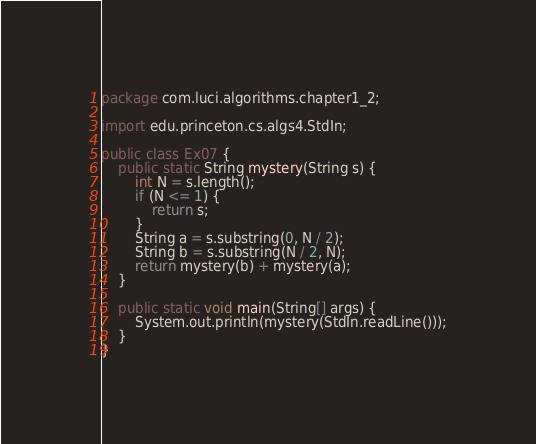Convert code to text. <code><loc_0><loc_0><loc_500><loc_500><_Java_>package com.luci.algorithms.chapter1_2;

import edu.princeton.cs.algs4.StdIn;

public class Ex07 {
	public static String mystery(String s) {
		int N = s.length();
		if (N <= 1) {
			return s;
		}
		String a = s.substring(0, N / 2);
		String b = s.substring(N / 2, N);
		return mystery(b) + mystery(a);
	}

	public static void main(String[] args) {
		System.out.println(mystery(StdIn.readLine()));
	}
}
</code> 